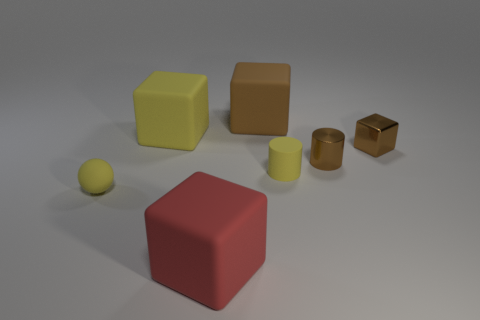Add 2 tiny red objects. How many objects exist? 9 Subtract all spheres. How many objects are left? 6 Subtract all yellow matte things. Subtract all big red cubes. How many objects are left? 3 Add 7 yellow objects. How many yellow objects are left? 10 Add 2 yellow matte objects. How many yellow matte objects exist? 5 Subtract 0 gray cubes. How many objects are left? 7 